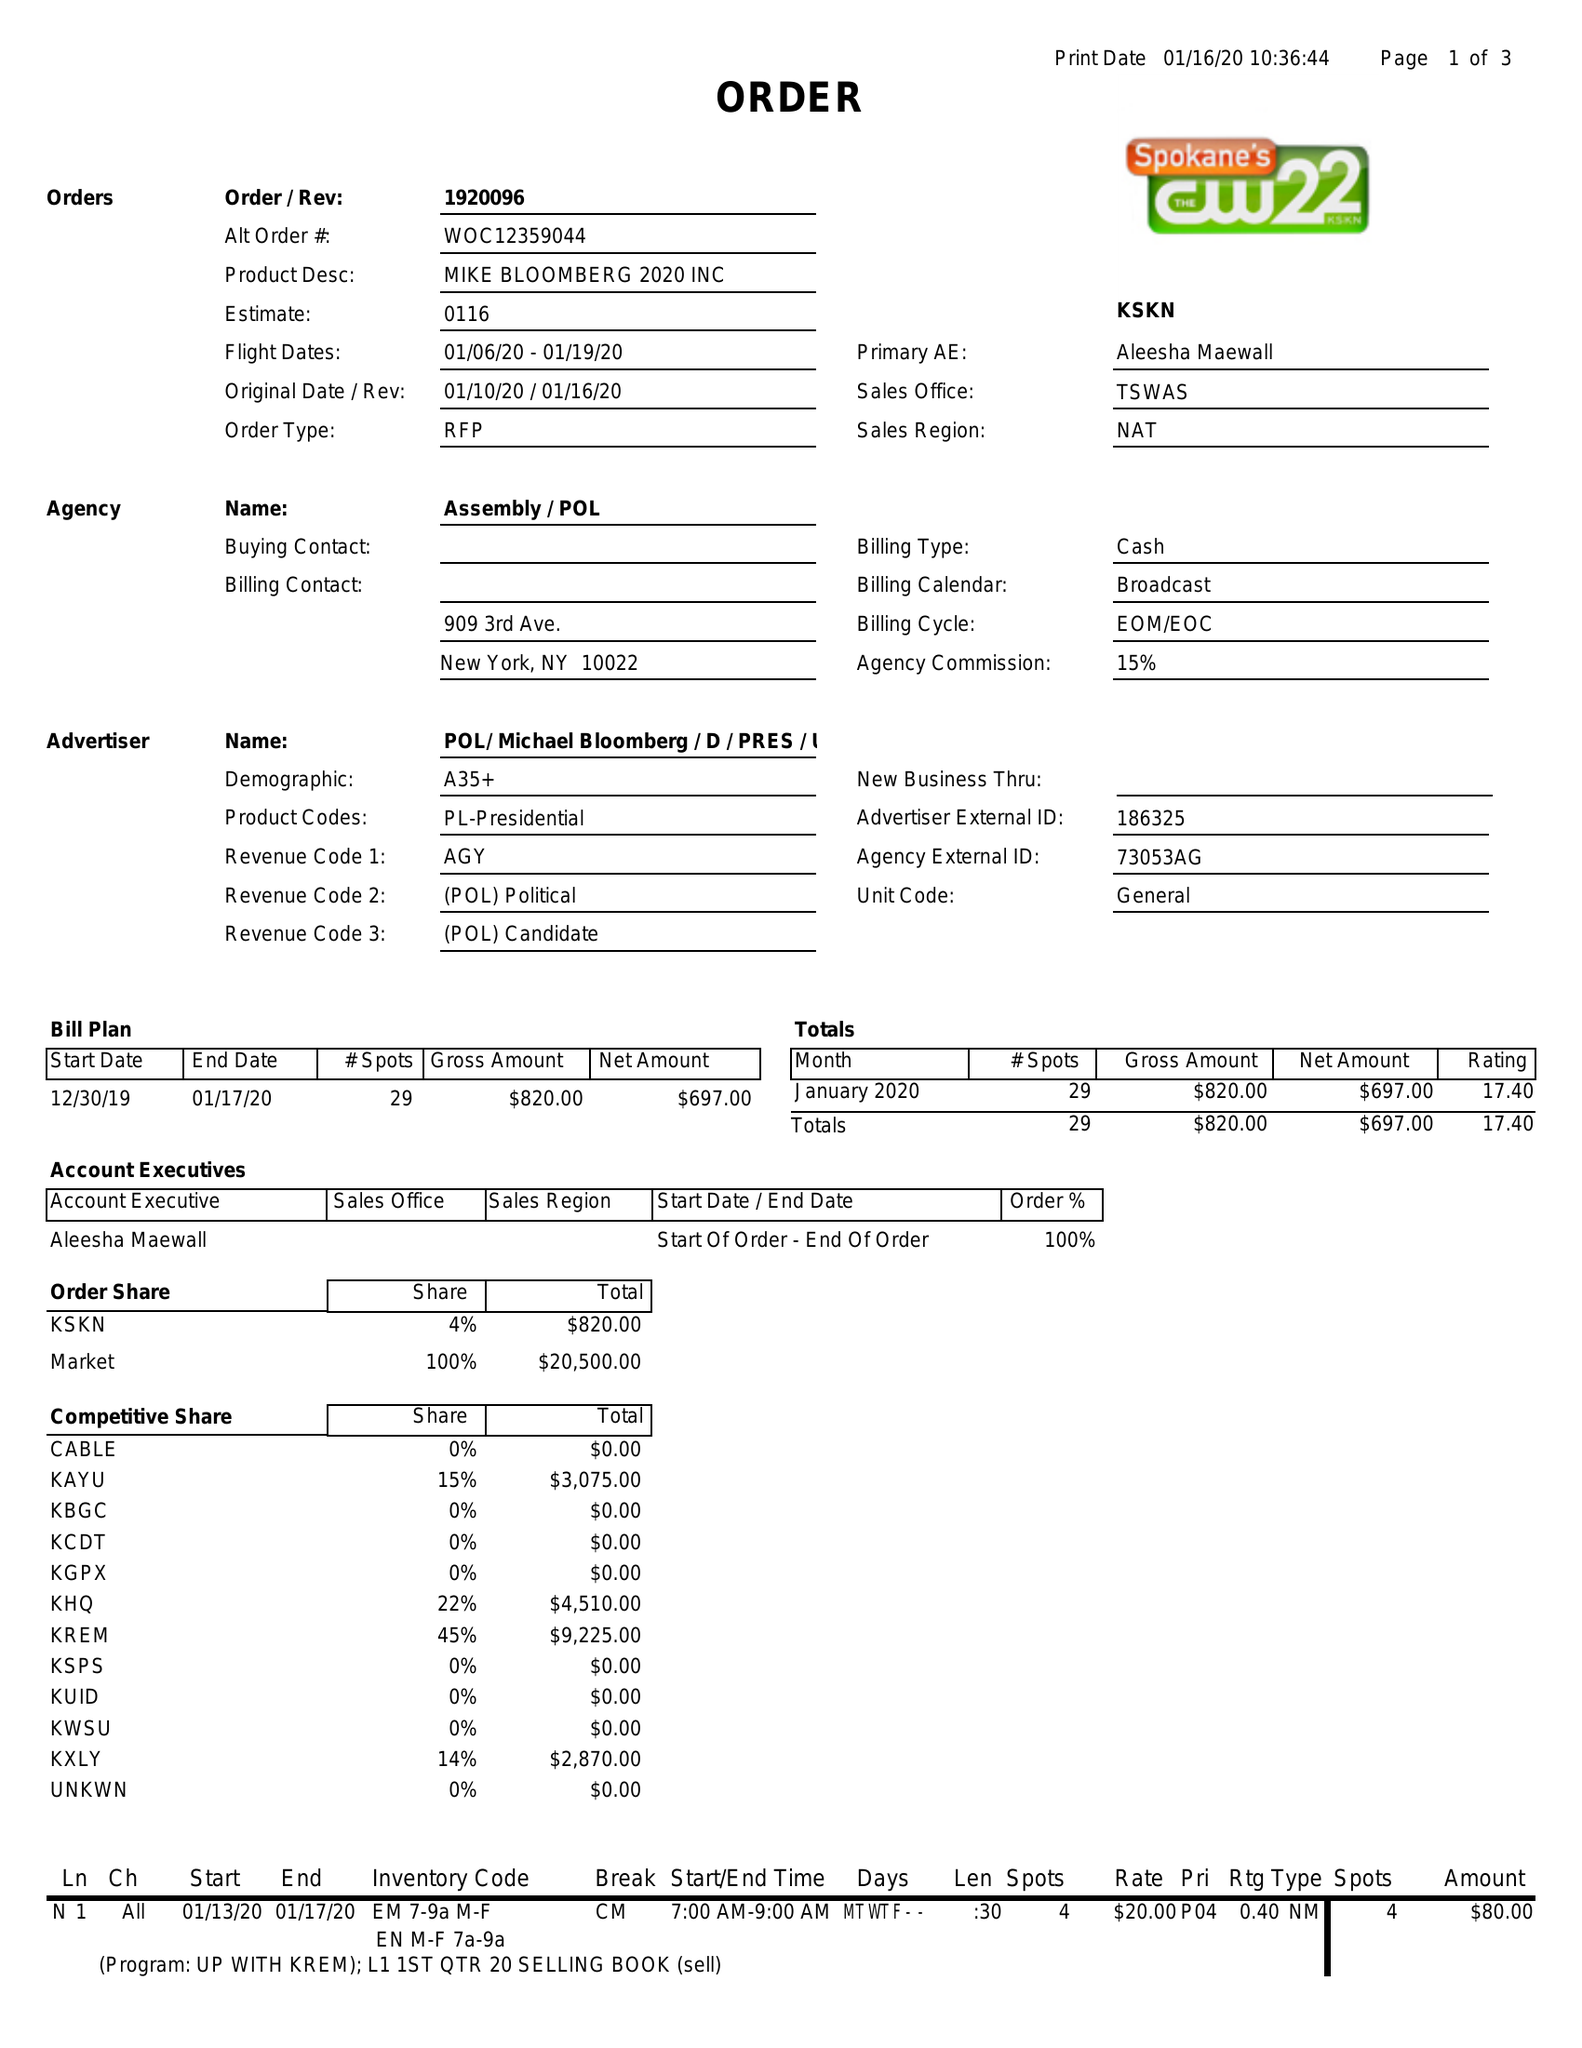What is the value for the gross_amount?
Answer the question using a single word or phrase. 820.00 